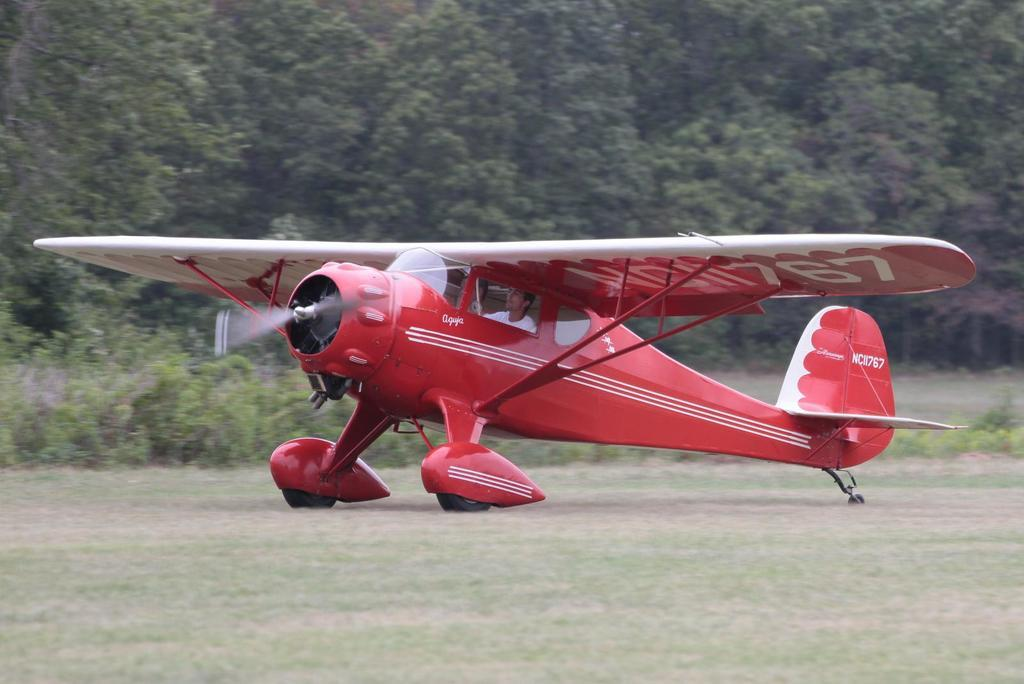What is the main subject of the image? The main subject of the image is an airplane. Where is the airplane located? The airplane is on a grassland with plants. Is there anyone inside the airplane? Yes, there is a person sitting in the airplane. What can be seen in the background of the image? There are trees in the background of the image. What type of breakfast is being served in the airplane? There is no indication of breakfast being served in the image, as it only shows an airplane on a grassland with a person inside. 